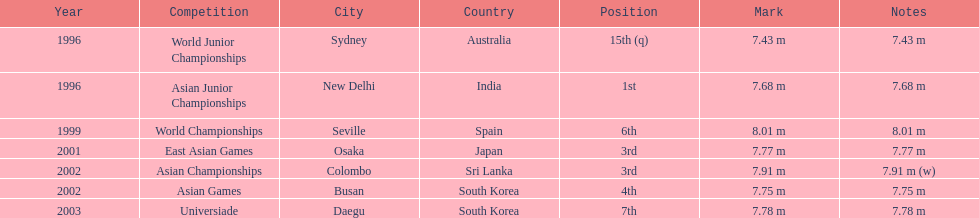Which year was his best jump? 1999. 